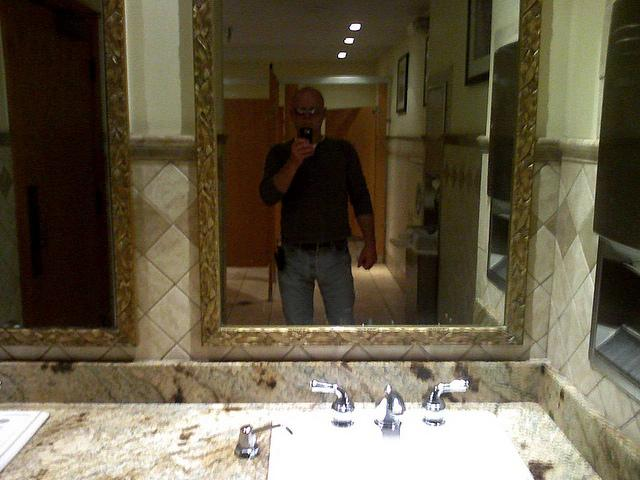Where does the man carry his cell phone? Please explain your reasoning. side holster. The man has a holder to carry his cell phone on his side. 